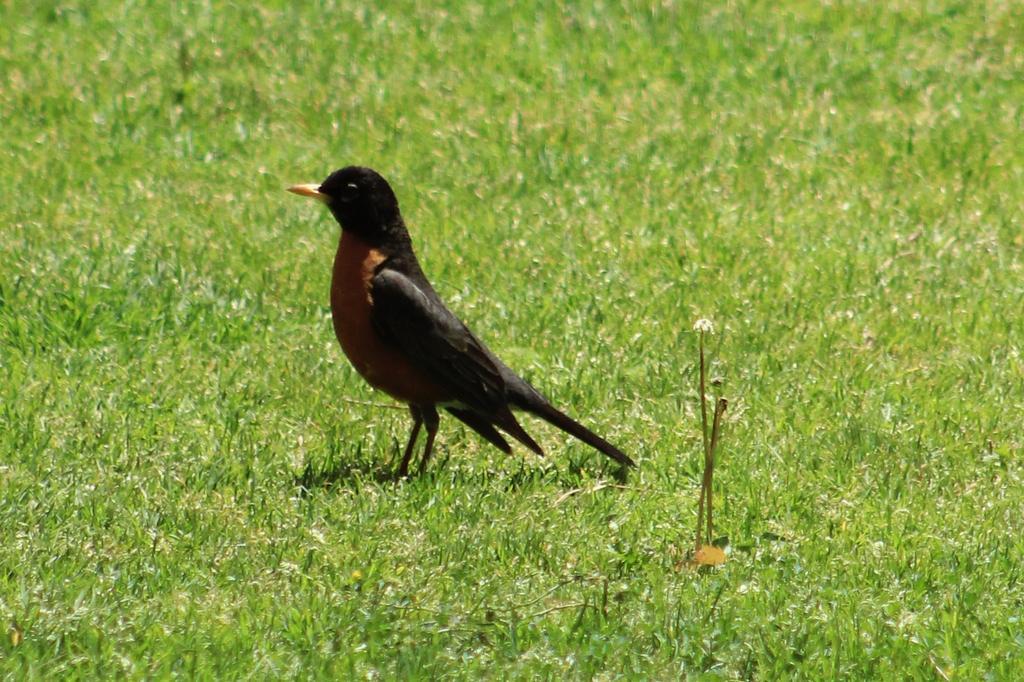How would you summarize this image in a sentence or two? In this image we can see a man standing on the ground. 